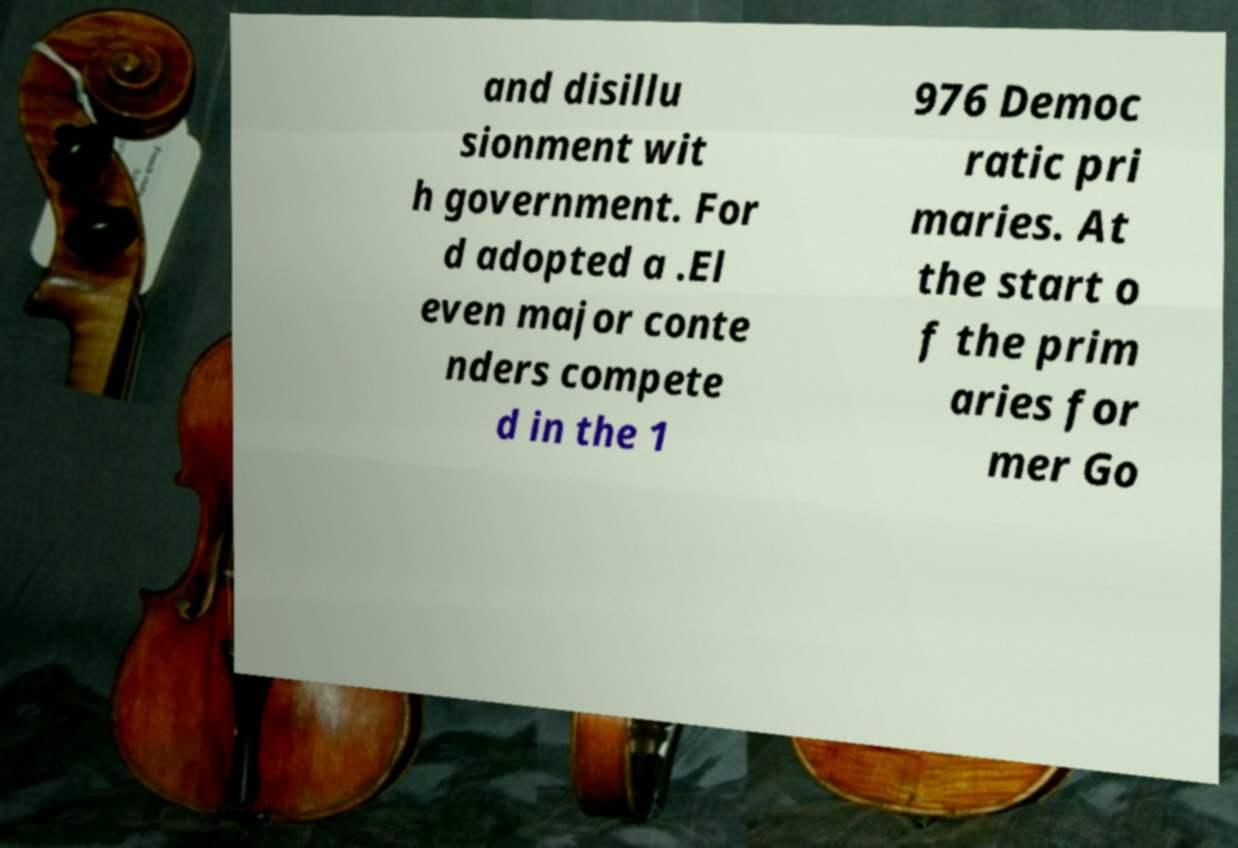There's text embedded in this image that I need extracted. Can you transcribe it verbatim? and disillu sionment wit h government. For d adopted a .El even major conte nders compete d in the 1 976 Democ ratic pri maries. At the start o f the prim aries for mer Go 